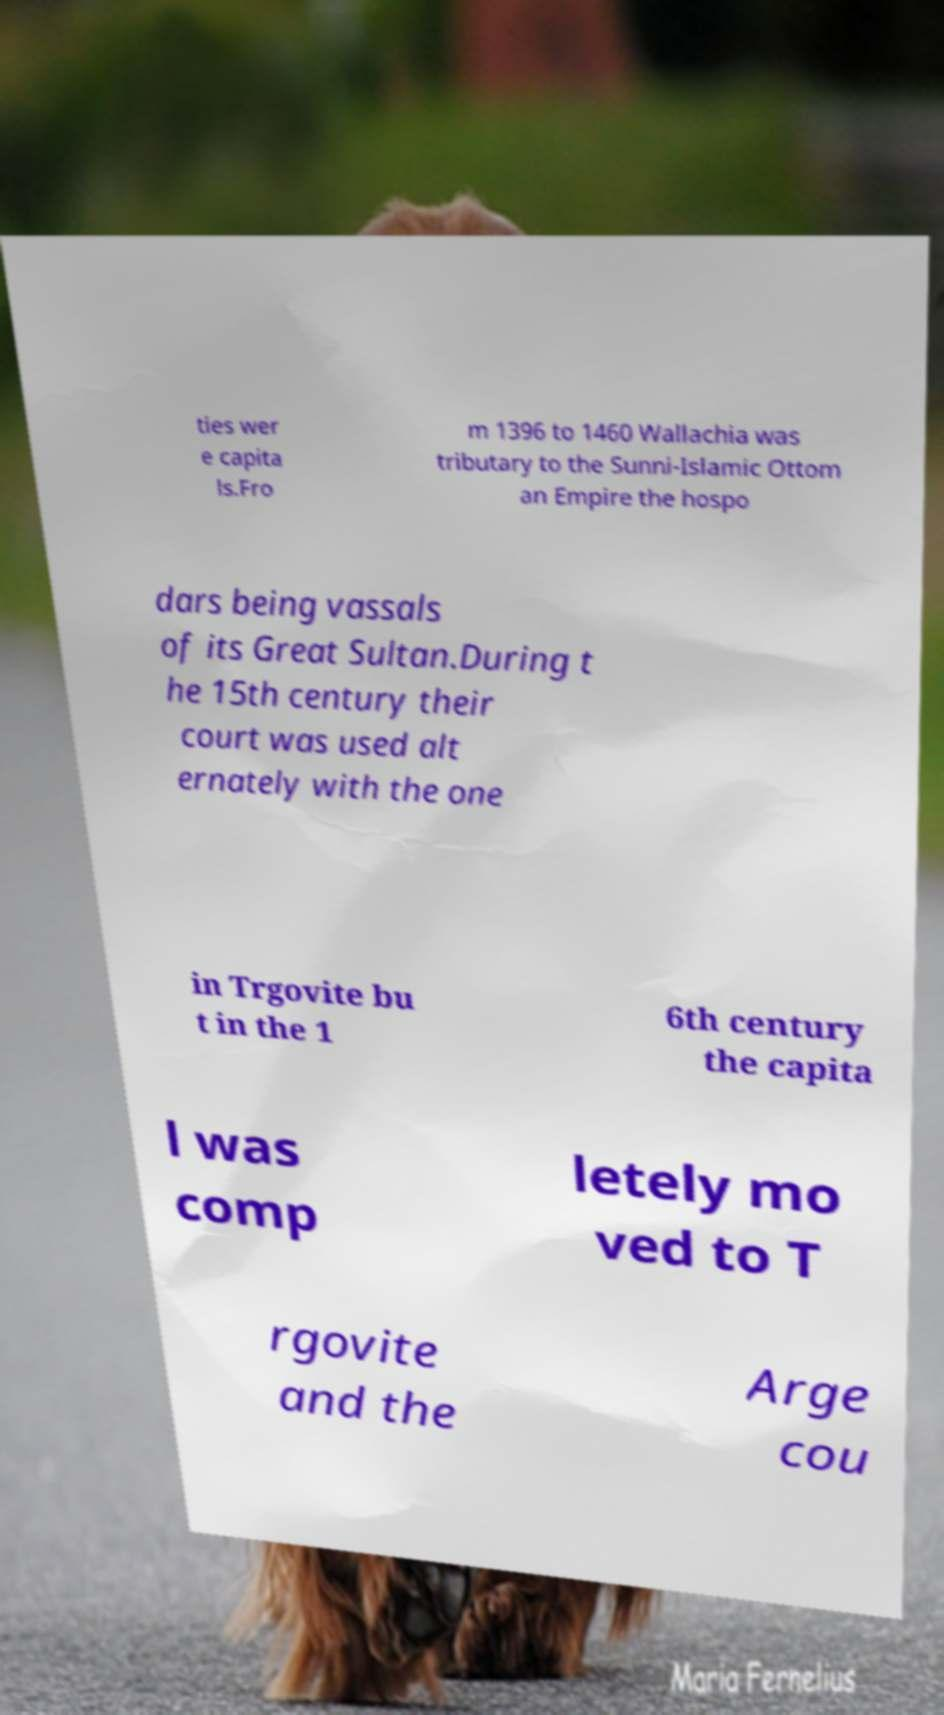Please identify and transcribe the text found in this image. ties wer e capita ls.Fro m 1396 to 1460 Wallachia was tributary to the Sunni-Islamic Ottom an Empire the hospo dars being vassals of its Great Sultan.During t he 15th century their court was used alt ernately with the one in Trgovite bu t in the 1 6th century the capita l was comp letely mo ved to T rgovite and the Arge cou 